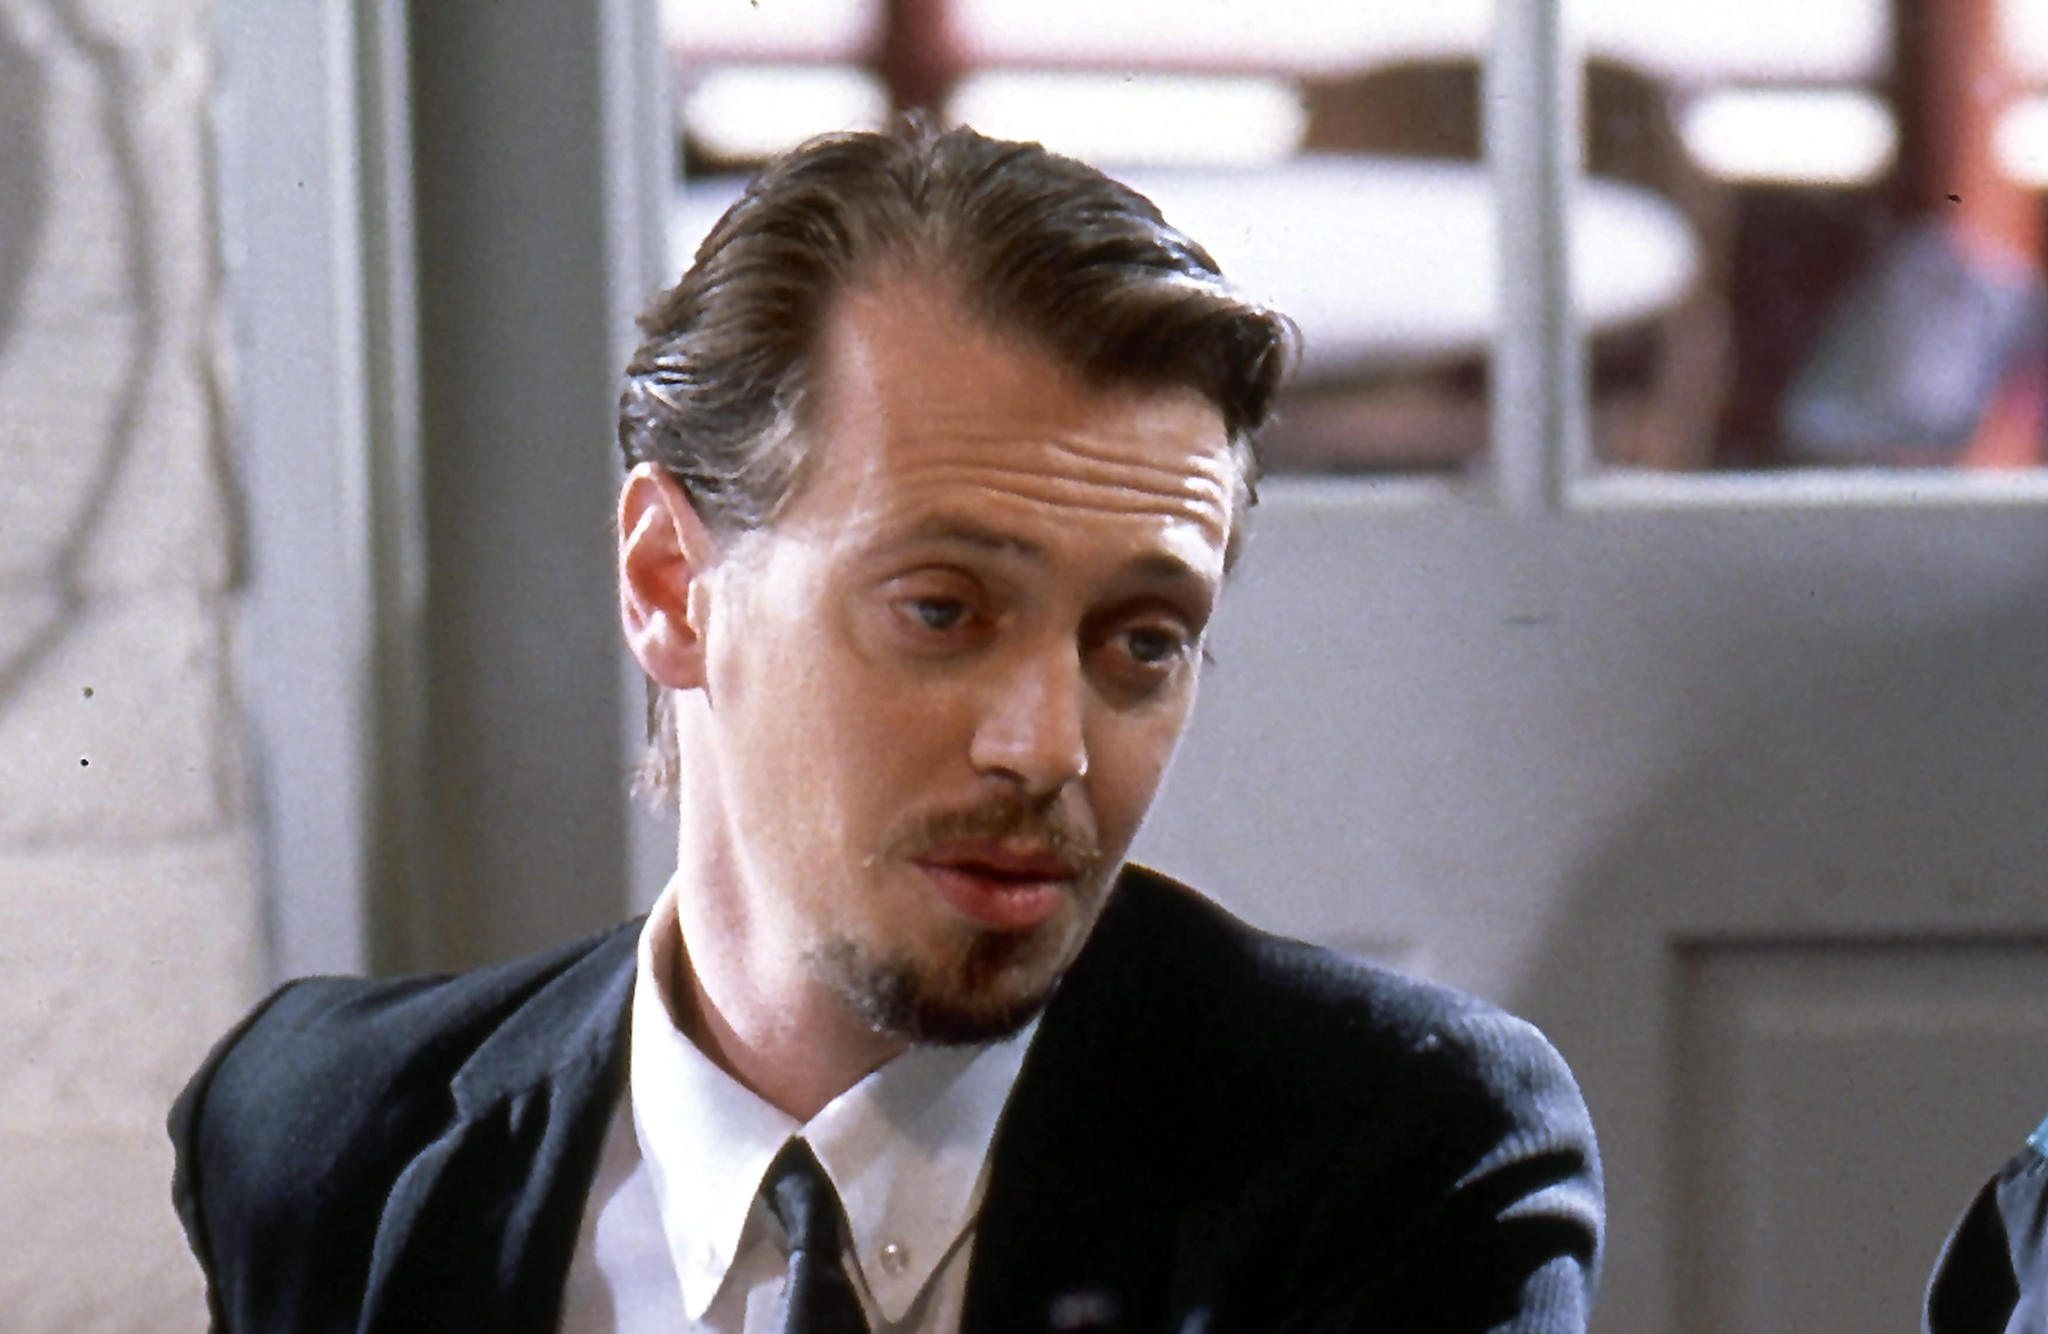Can you describe the setting of the image and the possible mood conveyed? The setting of the image appears to be a public establishment, likely a restaurant or cafe, as indicated by the blurred background elements. The lighting is somewhat soft but not too dim, suggesting it is either a well-lit area or perhaps daylight streaming in from nearby windows. This setting creates a neutral to slightly contemplative mood. The subject, dressed formally, is potentially engaged in a serious conversation or deep personal reflection. His thoughtful expression adds to the overall introspective atmosphere of the scene. What do you think the character might be thinking about in this moment? Considering the character, Mr. Pink from 'Reservoir Dogs', is known for his sharp and sometimes cynical outlook, he could be contemplating the aftermath of a significant heist gone awry. His expression suggests he might be weighing the consequences of his actions, perhaps questioning the trustworthiness of his fellow criminals or pondering his next move to ensure his survival. This moment captures the essence of his character—calculating, wary, and deeply analytical. If you had to imagine a completely wild scenario for this scene, what would it be? Imagine Mr. Pink, while in deep contemplation, suddenly realizes that he is not in a typical restaurant but in an offbeat, secret gathering of interdimensional time travelers. The blurred background is not of earthly origin but a soft focus of a portal to parallel universes. He is waiting for the arrival of a time-traveling contraband dealer, who is offering an artifact that could alter the course of reality as he knows it. This pivotal moment holds both anticipation and a profound sense of the unknown, transforming the mundane setting into an extraordinary crossroads of time and existence. 